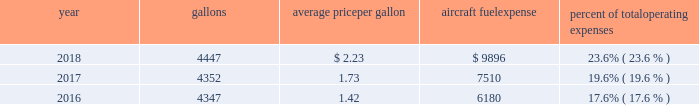The table shows annual aircraft fuel consumption and costs , including taxes , for our mainline and regional operations for 2018 , 2017 and 2016 ( gallons and aircraft fuel expense in millions ) .
Year gallons average price per gallon aircraft fuel expense percent of total operating expenses .
As of december 31 , 2018 , we did not have any fuel hedging contracts outstanding to hedge our fuel consumption .
As such , and assuming we do not enter into any future transactions to hedge our fuel consumption , we will continue to be fully exposed to fluctuations in fuel prices .
Our current policy is not to enter into transactions to hedge our fuel consumption , although we review that policy from time to time based on market conditions and other factors .
Fuel prices have fluctuated substantially over the past several years .
We cannot predict the future availability , price volatility or cost of aircraft fuel .
Natural disasters ( including hurricanes or similar events in the u.s .
Southeast and on the gulf coast where a significant portion of domestic refining capacity is located ) , political disruptions or wars involving oil-producing countries , economic sanctions imposed against oil-producing countries or specific industry participants , changes in fuel-related governmental policy , the strength of the u.s .
Dollar against foreign currencies , changes in the cost to transport or store petroleum products , changes in access to petroleum product pipelines and terminals , speculation in the energy futures markets , changes in aircraft fuel production capacity , environmental concerns and other unpredictable events may result in fuel supply shortages , distribution challenges , additional fuel price volatility and cost increases in the future .
See part i , item 1a .
Risk factors 2013 201cour business is very dependent on the price and availability of aircraft fuel .
Continued periods of high volatility in fuel costs , increased fuel prices or significant disruptions in the supply of aircraft fuel could have a significant negative impact on our operating results and liquidity . 201d seasonality and other factors due to the greater demand for air travel during the summer months , revenues in the airline industry in the second and third quarters of the year tend to be greater than revenues in the first and fourth quarters of the year .
General economic conditions , fears of terrorism or war , fare initiatives , fluctuations in fuel prices , labor actions , weather , natural disasters , outbreaks of disease and other factors could impact this seasonal pattern .
Therefore , our quarterly results of operations are not necessarily indicative of operating results for the entire year , and historical operating results in a quarterly or annual period are not necessarily indicative of future operating results .
Domestic and global regulatory landscape general airlines are subject to extensive domestic and international regulatory requirements .
Domestically , the dot and the federal aviation administration ( faa ) exercise significant regulatory authority over air carriers .
The dot , among other things , oversees domestic and international codeshare agreements , international route authorities , competition and consumer protection matters such as advertising , denied boarding compensation and baggage liability .
The antitrust division of the department of justice ( doj ) , along with the dot in certain instances , have jurisdiction over airline antitrust matters. .
What were total operating expenses in 2017? 
Computations: (7510 / 19.6%)
Answer: 38316.32653. 